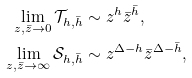<formula> <loc_0><loc_0><loc_500><loc_500>\lim _ { z , \bar { z } \rightarrow 0 } \mathcal { T } _ { h , \bar { h } } & \sim z ^ { h } \bar { z } ^ { \bar { h } } , \\ \lim _ { z , \bar { z } \rightarrow \infty } \mathcal { S } _ { h , \bar { h } } & \sim z ^ { \Delta - h } \bar { z } ^ { \Delta - \bar { h } } ,</formula> 